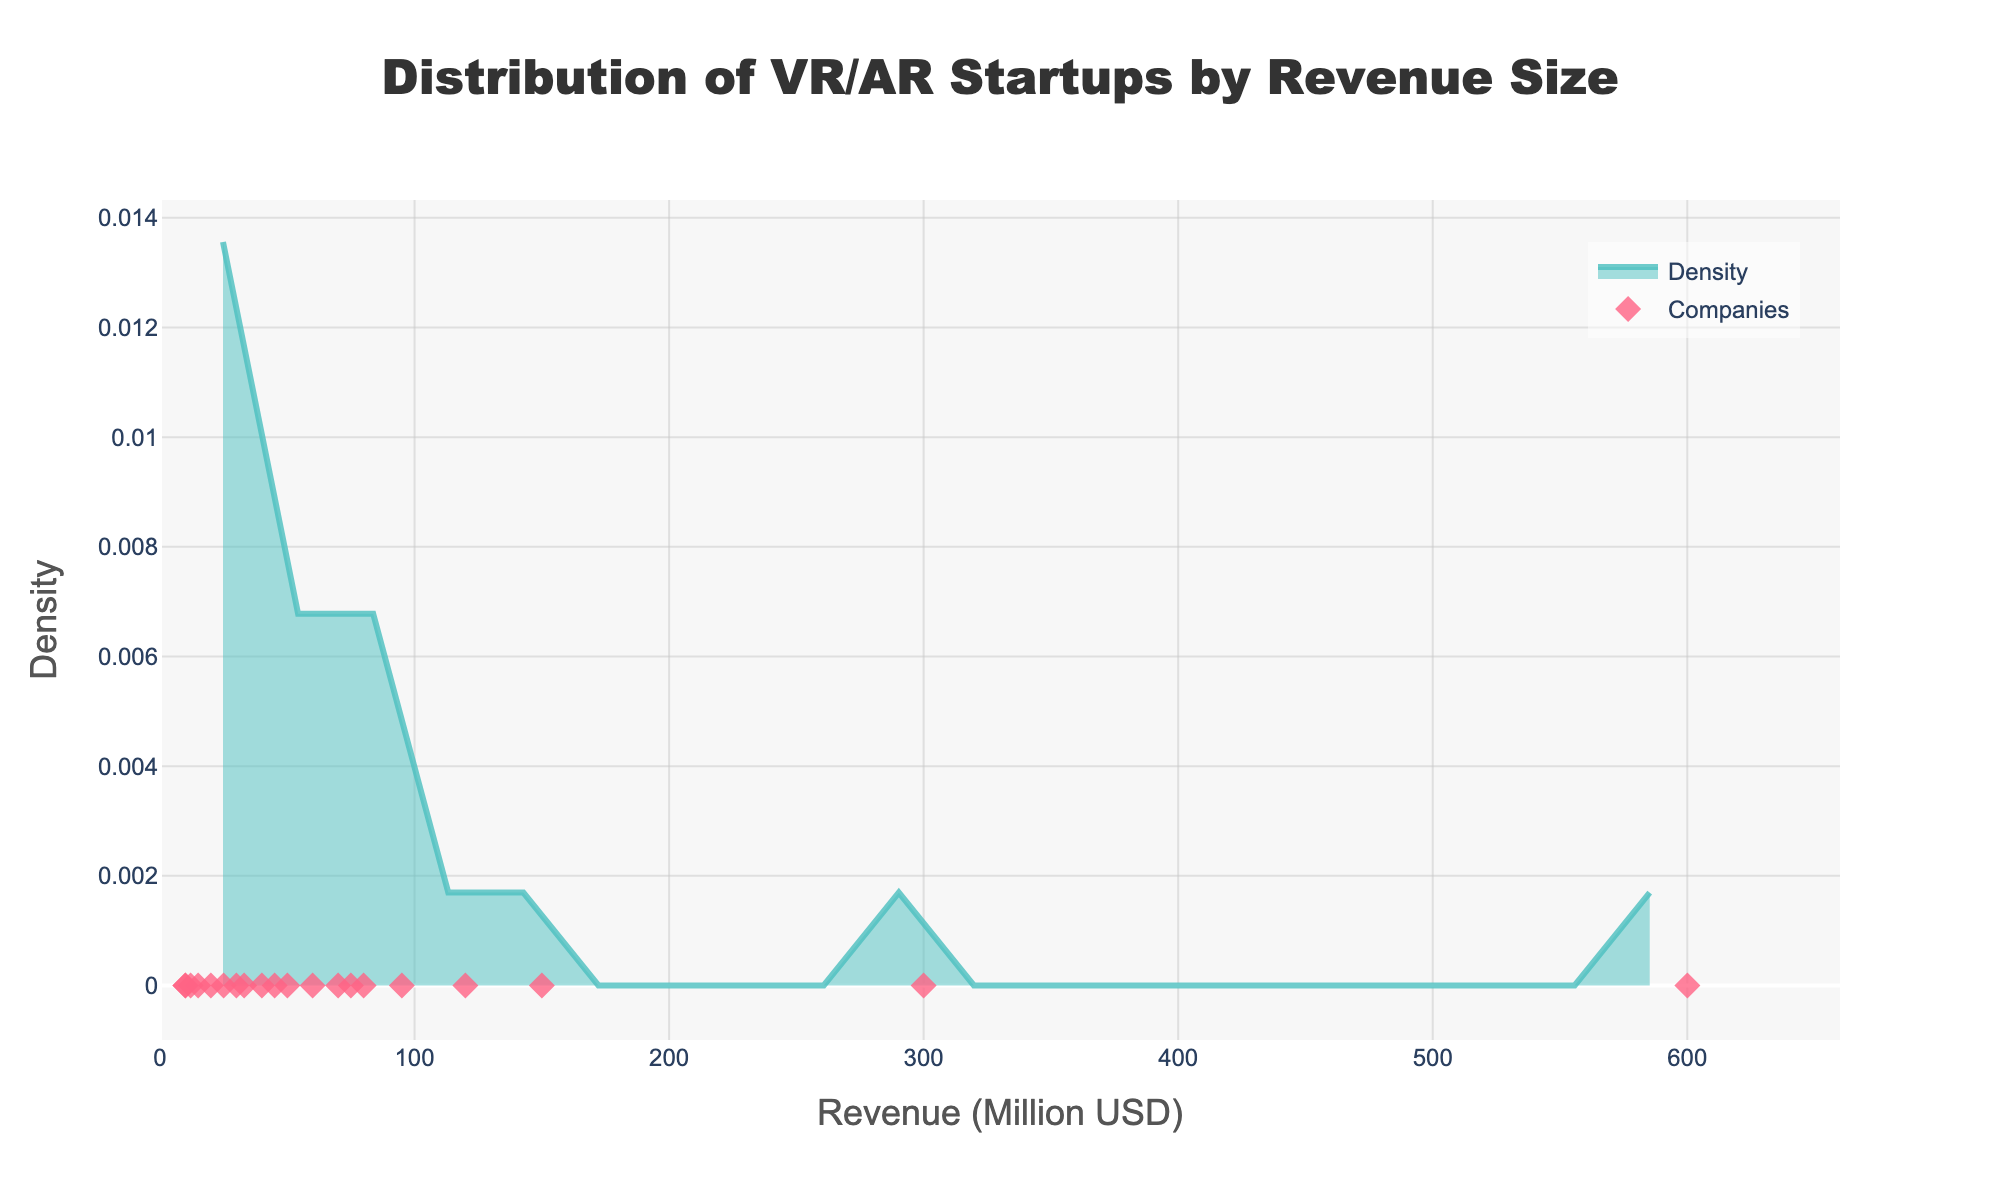What is the title of the figure? The title is usually found at the top of the figure and provides a summary of what the figure represents.
Answer: Distribution of VR/AR Startups by Revenue Size What does the x-axis represent? The x-axis in the figure typically represents the variable being measured, which in this case is labeled clearly.
Answer: Revenue (Million USD) How many different companies are represented by individual points on the plot? Individual points can be identified by the number of markers on the plot.
Answer: 20 What range of revenue is covered by the figure? By examining the range of the x-axis from the lowest revenue to the highest revenue value, we can determine the range. This information is visible on the x-axis scale.
Answer: From 10 to 600 million USD Where does the density curve peak? Observing the highest point(s) on the density curve tells us where the peak(s) occur on the x-axis.
Answer: Around 30-50 million USD Which company has the highest revenue, and what is that revenue? By identifying the furthest marker to the right, we can infer the company it represents and the corresponding revenue from the data points given.
Answer: Oculus, 600 million USD Is there more concentration of companies with lower revenues or higher revenues? Comparing the density along the x-axis, we can see where more companies tend to cluster.
Answer: Lower revenues What is the revenue of the company closest to the median value? Median revenue sorts all revenue values and picks the middle one. Visually, it is the point where half of the area under the density curve is to the left and half to the right.
Answer: NextVR, 50 million USD How does the revenue of Magic Leap compare with Meta Company? By locating the revenue points of both companies on the plot, we can compare their positions relative to each other.
Answer: Magic Leap has higher revenue than Meta Company Which revenue range has the least number of companies? Observing the segments of the x-axis with the fewest markers or noticing the flat regions of the density plot will indicate less concentration.
Answer: 500 - 600 million USD 